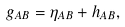Convert formula to latex. <formula><loc_0><loc_0><loc_500><loc_500>g _ { A B } = \eta _ { A B } + h _ { A B } ,</formula> 